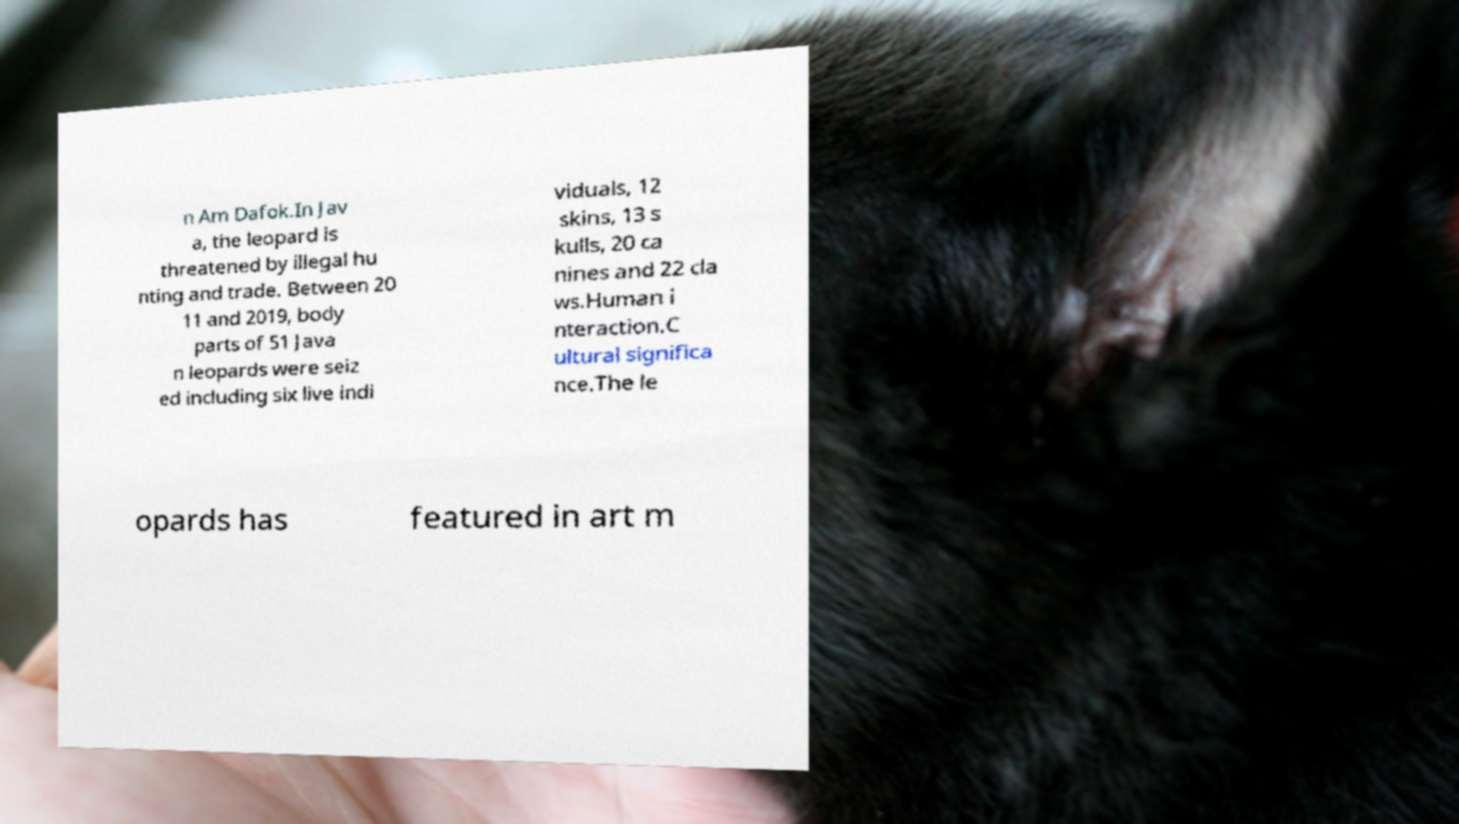I need the written content from this picture converted into text. Can you do that? n Am Dafok.In Jav a, the leopard is threatened by illegal hu nting and trade. Between 20 11 and 2019, body parts of 51 Java n leopards were seiz ed including six live indi viduals, 12 skins, 13 s kulls, 20 ca nines and 22 cla ws.Human i nteraction.C ultural significa nce.The le opards has featured in art m 